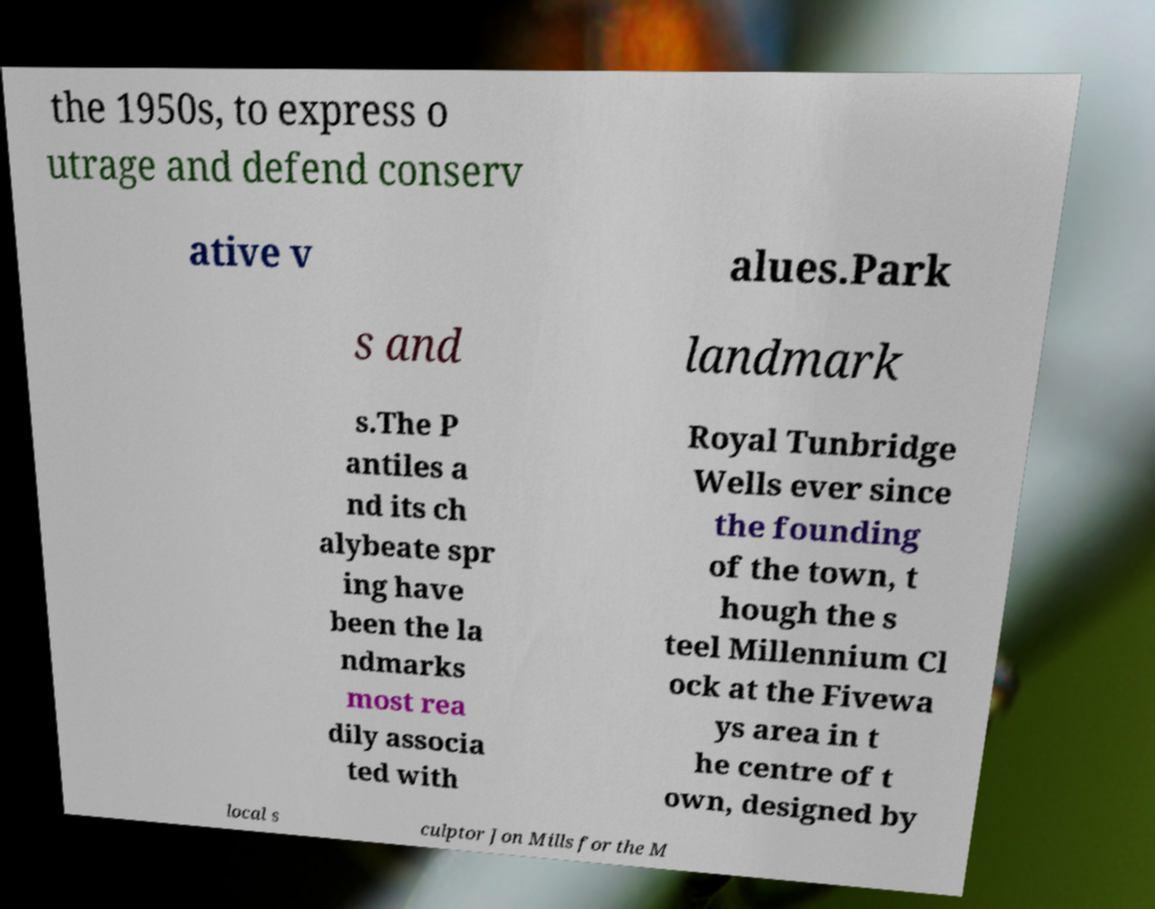Could you extract and type out the text from this image? the 1950s, to express o utrage and defend conserv ative v alues.Park s and landmark s.The P antiles a nd its ch alybeate spr ing have been the la ndmarks most rea dily associa ted with Royal Tunbridge Wells ever since the founding of the town, t hough the s teel Millennium Cl ock at the Fivewa ys area in t he centre of t own, designed by local s culptor Jon Mills for the M 